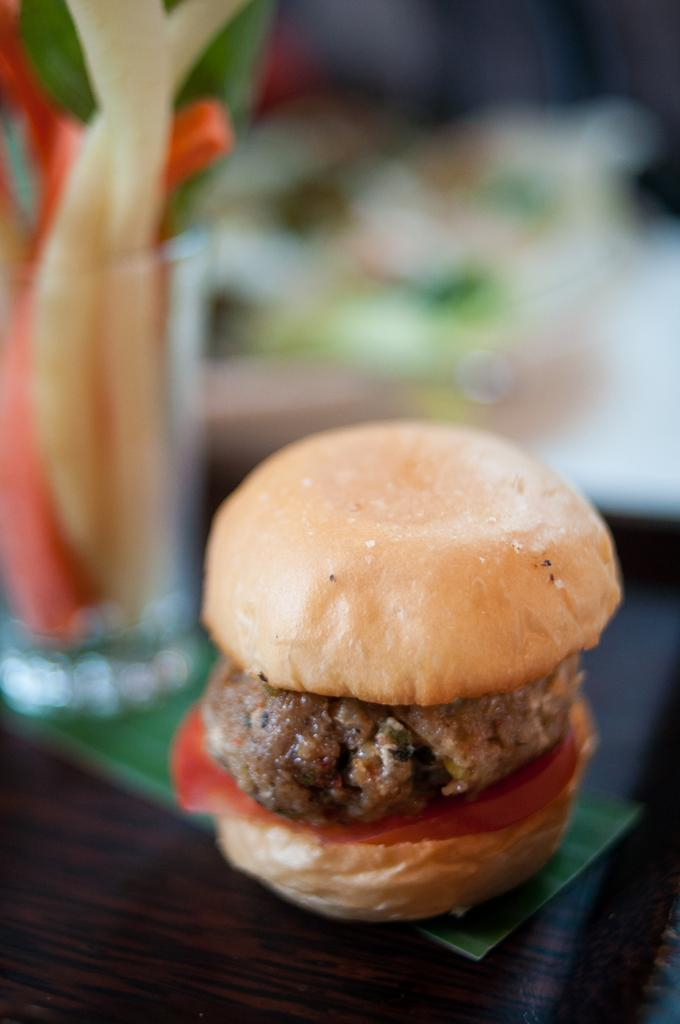What type of table is in the foreground of the image? There is a wooden table in the foreground of the image. What is placed on the wooden table? A glass and a burger are placed on the table. Can you describe the background of the image? The background of the image is blurry. What type of fire can be seen in the image? There is no fire present in the image. What type of minister is visible in the image? There is no minister present in the image. 